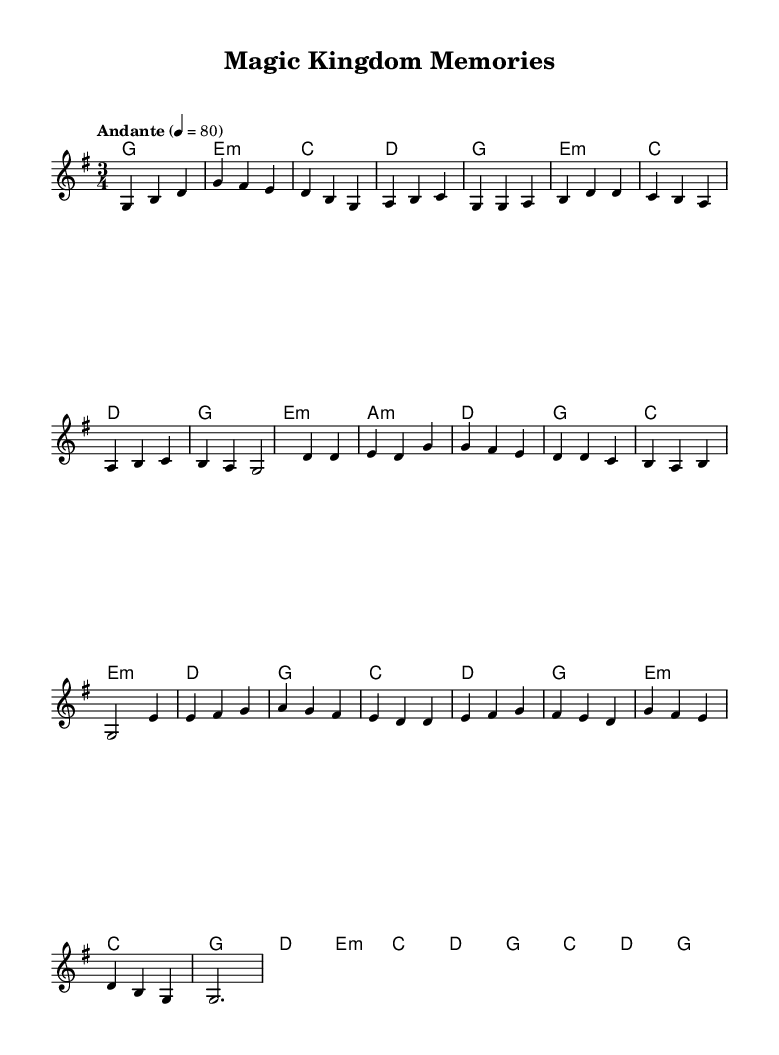What is the key signature of this music? The key signature is G major, as indicated by the presence of one sharp (F#) at the beginning of the staff.
Answer: G major What is the time signature of this music? The time signature is 3/4, shown on the sheet as a fraction near the beginning of the score, indicating three beats per measure.
Answer: 3/4 What is the tempo marking of this piece? The tempo marking specifies "Andante," indicating a moderately slow pace, as mentioned in the score.
Answer: Andante How many measures are in the chorus section? The chorus section consists of eight measures. This can be counted directly from the music notation segment labeled "Chorus."
Answer: 8 What is the last chord of the piece? The final chord is G major, as indicated by the chord symbol shown at the end of the score.
Answer: G In which section does the bridge appear? The bridge is indicated between the chorus and the outro, and is labeled clearly as "Bridge" in the corresponding part of the score.
Answer: Bridge What is the melodic pattern of the intro? The melodic pattern of the intro consists of four measures and is represented by the given sequence in the melody section.
Answer: g b d, g fis e, d b g, a b c 